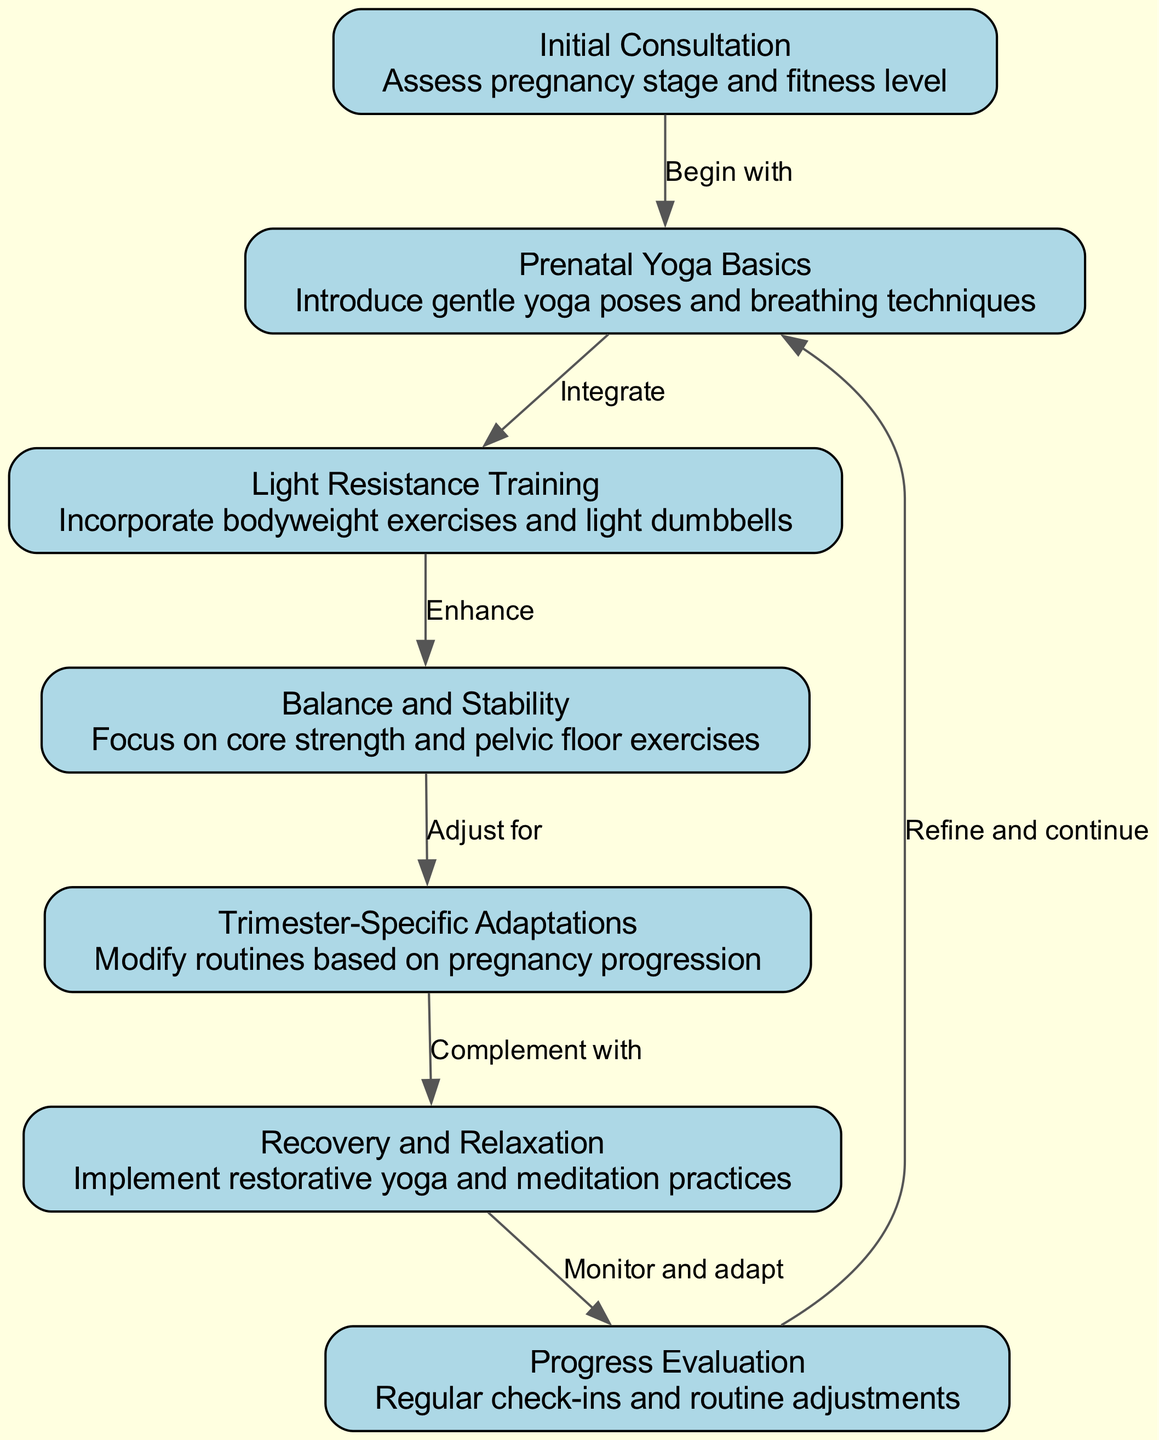What is the first step in the pathway? The first node in the diagram is labeled "Initial Consultation," indicating that this is the starting point of the pathway where an assessment of pregnancy stage and fitness level is conducted.
Answer: Initial Consultation How many nodes are in the diagram? By counting the listed nodes, there are a total of seven distinct nodes present in the diagram, each representing a specific step in the prenatal fitness journey.
Answer: 7 What is the relationship between "Light Resistance Training" and "Balance and Stability"? The diagram shows that "Light Resistance Training" leads to "Balance and Stability," signifying that after introducing resistance training, the next focus is on enhancing core strength and stability.
Answer: Enhance What complements "Trimester-Specific Adaptations" in the pathway? According to the diagram, "Trimester-Specific Adaptations" is complemented by "Recovery and Relaxation," indicating a balance between modifying routines and restorative practices during the prenatal journey.
Answer: Recovery and Relaxation What is the final evaluation step? The last node in the diagram is "Progress Evaluation," which signifies that regular check-ins and routine adjustments are made at this stage to ensure effective monitoring of the fitness journey.
Answer: Progress Evaluation How do participants "Refine and continue" the cycle? The diagram indicates that after "Progress Evaluation," participants may "Refine and continue" the journey by returning to "Prenatal Yoga Basics," suggesting an iterative approach to their fitness routine.
Answer: Refine and continue Which node focuses on core strength? In the diagram, the node labeled "Balance and Stability" specifically focuses on core strength and pelvic floor exercises, indicating its importance in the overall fitness regimen.
Answer: Balance and Stability What is the primary focus of the "Initial Consultation"? The primary focus of the "Initial Consultation" node is to assess pregnancy stage and fitness level, which sets the tone for the subsequent fitness journey.
Answer: Assess pregnancy stage and fitness level 